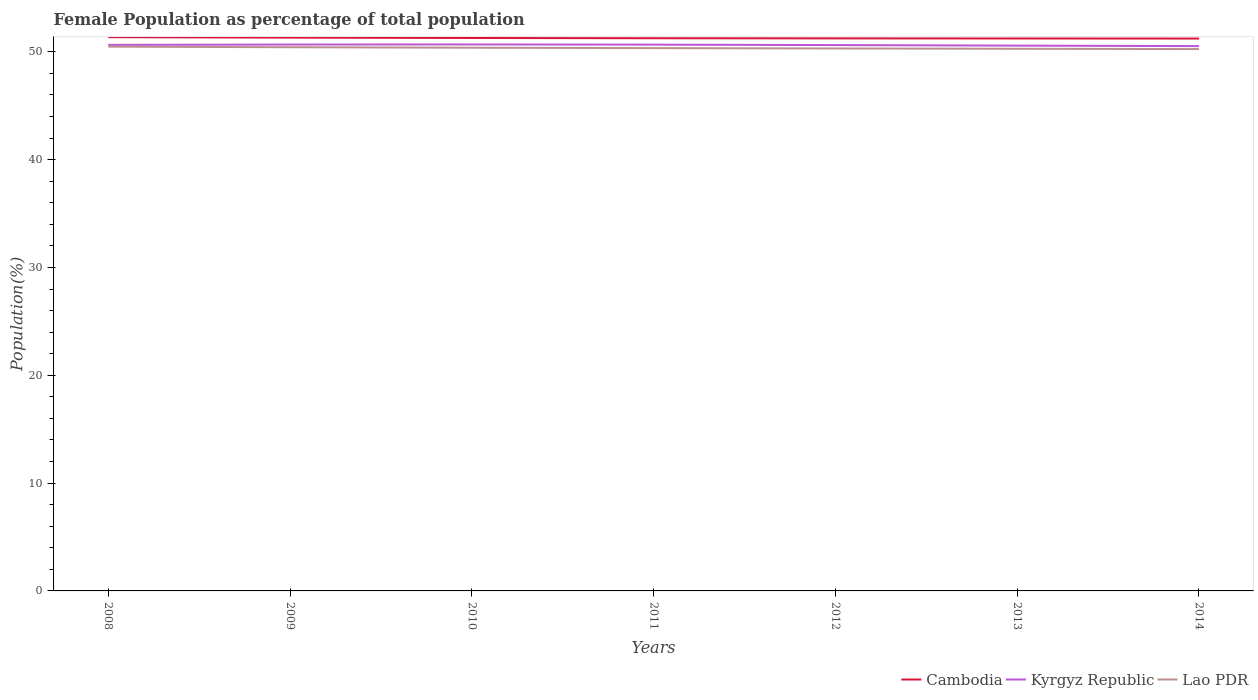How many different coloured lines are there?
Offer a very short reply. 3. Does the line corresponding to Lao PDR intersect with the line corresponding to Kyrgyz Republic?
Make the answer very short. No. Across all years, what is the maximum female population in in Cambodia?
Your answer should be compact. 51.23. What is the total female population in in Kyrgyz Republic in the graph?
Give a very brief answer. -0.03. What is the difference between the highest and the second highest female population in in Cambodia?
Ensure brevity in your answer.  0.13. What is the difference between the highest and the lowest female population in in Kyrgyz Republic?
Keep it short and to the point. 4. Is the female population in in Lao PDR strictly greater than the female population in in Cambodia over the years?
Ensure brevity in your answer.  Yes. How many years are there in the graph?
Provide a succinct answer. 7. Does the graph contain any zero values?
Your response must be concise. No. Where does the legend appear in the graph?
Give a very brief answer. Bottom right. How many legend labels are there?
Your answer should be compact. 3. What is the title of the graph?
Your response must be concise. Female Population as percentage of total population. Does "United States" appear as one of the legend labels in the graph?
Offer a terse response. No. What is the label or title of the X-axis?
Provide a succinct answer. Years. What is the label or title of the Y-axis?
Offer a very short reply. Population(%). What is the Population(%) in Cambodia in 2008?
Give a very brief answer. 51.36. What is the Population(%) of Kyrgyz Republic in 2008?
Make the answer very short. 50.65. What is the Population(%) of Lao PDR in 2008?
Keep it short and to the point. 50.48. What is the Population(%) in Cambodia in 2009?
Make the answer very short. 51.32. What is the Population(%) of Kyrgyz Republic in 2009?
Provide a succinct answer. 50.68. What is the Population(%) of Lao PDR in 2009?
Provide a short and direct response. 50.43. What is the Population(%) in Cambodia in 2010?
Your answer should be very brief. 51.29. What is the Population(%) in Kyrgyz Republic in 2010?
Keep it short and to the point. 50.69. What is the Population(%) in Lao PDR in 2010?
Make the answer very short. 50.38. What is the Population(%) in Cambodia in 2011?
Give a very brief answer. 51.26. What is the Population(%) of Kyrgyz Republic in 2011?
Ensure brevity in your answer.  50.67. What is the Population(%) of Lao PDR in 2011?
Provide a succinct answer. 50.35. What is the Population(%) in Cambodia in 2012?
Make the answer very short. 51.25. What is the Population(%) in Kyrgyz Republic in 2012?
Your answer should be compact. 50.63. What is the Population(%) of Lao PDR in 2012?
Ensure brevity in your answer.  50.31. What is the Population(%) in Cambodia in 2013?
Offer a very short reply. 51.24. What is the Population(%) of Kyrgyz Republic in 2013?
Your response must be concise. 50.58. What is the Population(%) in Lao PDR in 2013?
Offer a very short reply. 50.28. What is the Population(%) of Cambodia in 2014?
Provide a short and direct response. 51.23. What is the Population(%) of Kyrgyz Republic in 2014?
Make the answer very short. 50.53. What is the Population(%) in Lao PDR in 2014?
Make the answer very short. 50.26. Across all years, what is the maximum Population(%) in Cambodia?
Give a very brief answer. 51.36. Across all years, what is the maximum Population(%) of Kyrgyz Republic?
Keep it short and to the point. 50.69. Across all years, what is the maximum Population(%) in Lao PDR?
Offer a terse response. 50.48. Across all years, what is the minimum Population(%) of Cambodia?
Give a very brief answer. 51.23. Across all years, what is the minimum Population(%) of Kyrgyz Republic?
Offer a very short reply. 50.53. Across all years, what is the minimum Population(%) of Lao PDR?
Offer a terse response. 50.26. What is the total Population(%) of Cambodia in the graph?
Provide a succinct answer. 358.95. What is the total Population(%) of Kyrgyz Republic in the graph?
Your response must be concise. 354.42. What is the total Population(%) of Lao PDR in the graph?
Provide a succinct answer. 352.5. What is the difference between the Population(%) of Cambodia in 2008 and that in 2009?
Ensure brevity in your answer.  0.04. What is the difference between the Population(%) of Kyrgyz Republic in 2008 and that in 2009?
Give a very brief answer. -0.03. What is the difference between the Population(%) in Lao PDR in 2008 and that in 2009?
Ensure brevity in your answer.  0.05. What is the difference between the Population(%) in Cambodia in 2008 and that in 2010?
Your answer should be compact. 0.08. What is the difference between the Population(%) of Kyrgyz Republic in 2008 and that in 2010?
Make the answer very short. -0.04. What is the difference between the Population(%) in Lao PDR in 2008 and that in 2010?
Give a very brief answer. 0.1. What is the difference between the Population(%) in Cambodia in 2008 and that in 2011?
Offer a terse response. 0.1. What is the difference between the Population(%) in Kyrgyz Republic in 2008 and that in 2011?
Your response must be concise. -0.02. What is the difference between the Population(%) of Lao PDR in 2008 and that in 2011?
Your response must be concise. 0.14. What is the difference between the Population(%) in Cambodia in 2008 and that in 2012?
Provide a short and direct response. 0.11. What is the difference between the Population(%) of Kyrgyz Republic in 2008 and that in 2012?
Your answer should be very brief. 0.02. What is the difference between the Population(%) in Lao PDR in 2008 and that in 2012?
Give a very brief answer. 0.17. What is the difference between the Population(%) of Cambodia in 2008 and that in 2013?
Your answer should be compact. 0.12. What is the difference between the Population(%) of Kyrgyz Republic in 2008 and that in 2013?
Provide a succinct answer. 0.07. What is the difference between the Population(%) of Lao PDR in 2008 and that in 2013?
Offer a terse response. 0.2. What is the difference between the Population(%) in Cambodia in 2008 and that in 2014?
Provide a succinct answer. 0.13. What is the difference between the Population(%) of Kyrgyz Republic in 2008 and that in 2014?
Your response must be concise. 0.11. What is the difference between the Population(%) of Lao PDR in 2008 and that in 2014?
Your answer should be compact. 0.22. What is the difference between the Population(%) of Cambodia in 2009 and that in 2010?
Offer a very short reply. 0.03. What is the difference between the Population(%) in Kyrgyz Republic in 2009 and that in 2010?
Keep it short and to the point. -0.01. What is the difference between the Population(%) in Lao PDR in 2009 and that in 2010?
Make the answer very short. 0.05. What is the difference between the Population(%) in Cambodia in 2009 and that in 2011?
Make the answer very short. 0.06. What is the difference between the Population(%) of Kyrgyz Republic in 2009 and that in 2011?
Make the answer very short. 0.01. What is the difference between the Population(%) of Lao PDR in 2009 and that in 2011?
Provide a short and direct response. 0.08. What is the difference between the Population(%) of Cambodia in 2009 and that in 2012?
Make the answer very short. 0.07. What is the difference between the Population(%) in Kyrgyz Republic in 2009 and that in 2012?
Ensure brevity in your answer.  0.05. What is the difference between the Population(%) of Lao PDR in 2009 and that in 2012?
Your answer should be compact. 0.12. What is the difference between the Population(%) in Cambodia in 2009 and that in 2013?
Offer a terse response. 0.08. What is the difference between the Population(%) in Kyrgyz Republic in 2009 and that in 2013?
Provide a short and direct response. 0.1. What is the difference between the Population(%) in Lao PDR in 2009 and that in 2013?
Provide a short and direct response. 0.14. What is the difference between the Population(%) in Cambodia in 2009 and that in 2014?
Offer a very short reply. 0.09. What is the difference between the Population(%) in Kyrgyz Republic in 2009 and that in 2014?
Your answer should be compact. 0.15. What is the difference between the Population(%) of Lao PDR in 2009 and that in 2014?
Your answer should be compact. 0.17. What is the difference between the Population(%) in Cambodia in 2010 and that in 2011?
Your answer should be compact. 0.02. What is the difference between the Population(%) of Kyrgyz Republic in 2010 and that in 2011?
Provide a succinct answer. 0.02. What is the difference between the Population(%) of Lao PDR in 2010 and that in 2011?
Give a very brief answer. 0.04. What is the difference between the Population(%) of Cambodia in 2010 and that in 2012?
Give a very brief answer. 0.04. What is the difference between the Population(%) of Kyrgyz Republic in 2010 and that in 2012?
Your response must be concise. 0.06. What is the difference between the Population(%) of Lao PDR in 2010 and that in 2012?
Offer a terse response. 0.07. What is the difference between the Population(%) in Cambodia in 2010 and that in 2013?
Make the answer very short. 0.05. What is the difference between the Population(%) of Kyrgyz Republic in 2010 and that in 2013?
Your answer should be very brief. 0.11. What is the difference between the Population(%) in Lao PDR in 2010 and that in 2013?
Offer a very short reply. 0.1. What is the difference between the Population(%) in Cambodia in 2010 and that in 2014?
Offer a very short reply. 0.05. What is the difference between the Population(%) in Kyrgyz Republic in 2010 and that in 2014?
Your response must be concise. 0.16. What is the difference between the Population(%) of Lao PDR in 2010 and that in 2014?
Provide a short and direct response. 0.13. What is the difference between the Population(%) in Cambodia in 2011 and that in 2012?
Provide a succinct answer. 0.01. What is the difference between the Population(%) of Kyrgyz Republic in 2011 and that in 2012?
Your answer should be compact. 0.04. What is the difference between the Population(%) in Lao PDR in 2011 and that in 2012?
Your answer should be very brief. 0.03. What is the difference between the Population(%) of Cambodia in 2011 and that in 2013?
Your answer should be compact. 0.02. What is the difference between the Population(%) of Kyrgyz Republic in 2011 and that in 2013?
Your response must be concise. 0.09. What is the difference between the Population(%) in Lao PDR in 2011 and that in 2013?
Your answer should be compact. 0.06. What is the difference between the Population(%) in Cambodia in 2011 and that in 2014?
Ensure brevity in your answer.  0.03. What is the difference between the Population(%) of Kyrgyz Republic in 2011 and that in 2014?
Give a very brief answer. 0.14. What is the difference between the Population(%) of Lao PDR in 2011 and that in 2014?
Provide a short and direct response. 0.09. What is the difference between the Population(%) of Cambodia in 2012 and that in 2013?
Keep it short and to the point. 0.01. What is the difference between the Population(%) of Kyrgyz Republic in 2012 and that in 2013?
Your answer should be compact. 0.05. What is the difference between the Population(%) of Lao PDR in 2012 and that in 2013?
Make the answer very short. 0.03. What is the difference between the Population(%) of Cambodia in 2012 and that in 2014?
Provide a short and direct response. 0.02. What is the difference between the Population(%) of Kyrgyz Republic in 2012 and that in 2014?
Offer a terse response. 0.1. What is the difference between the Population(%) of Lao PDR in 2012 and that in 2014?
Give a very brief answer. 0.06. What is the difference between the Population(%) of Cambodia in 2013 and that in 2014?
Provide a short and direct response. 0.01. What is the difference between the Population(%) of Kyrgyz Republic in 2013 and that in 2014?
Your answer should be compact. 0.05. What is the difference between the Population(%) of Lao PDR in 2013 and that in 2014?
Offer a very short reply. 0.03. What is the difference between the Population(%) of Cambodia in 2008 and the Population(%) of Kyrgyz Republic in 2009?
Provide a short and direct response. 0.68. What is the difference between the Population(%) in Cambodia in 2008 and the Population(%) in Lao PDR in 2009?
Keep it short and to the point. 0.93. What is the difference between the Population(%) of Kyrgyz Republic in 2008 and the Population(%) of Lao PDR in 2009?
Make the answer very short. 0.22. What is the difference between the Population(%) of Cambodia in 2008 and the Population(%) of Kyrgyz Republic in 2010?
Offer a terse response. 0.67. What is the difference between the Population(%) in Kyrgyz Republic in 2008 and the Population(%) in Lao PDR in 2010?
Ensure brevity in your answer.  0.26. What is the difference between the Population(%) of Cambodia in 2008 and the Population(%) of Kyrgyz Republic in 2011?
Offer a terse response. 0.69. What is the difference between the Population(%) in Cambodia in 2008 and the Population(%) in Lao PDR in 2011?
Offer a terse response. 1.02. What is the difference between the Population(%) in Kyrgyz Republic in 2008 and the Population(%) in Lao PDR in 2011?
Ensure brevity in your answer.  0.3. What is the difference between the Population(%) in Cambodia in 2008 and the Population(%) in Kyrgyz Republic in 2012?
Your answer should be very brief. 0.73. What is the difference between the Population(%) in Cambodia in 2008 and the Population(%) in Lao PDR in 2012?
Keep it short and to the point. 1.05. What is the difference between the Population(%) of Kyrgyz Republic in 2008 and the Population(%) of Lao PDR in 2012?
Provide a short and direct response. 0.33. What is the difference between the Population(%) in Cambodia in 2008 and the Population(%) in Kyrgyz Republic in 2013?
Ensure brevity in your answer.  0.78. What is the difference between the Population(%) of Cambodia in 2008 and the Population(%) of Lao PDR in 2013?
Offer a terse response. 1.08. What is the difference between the Population(%) of Kyrgyz Republic in 2008 and the Population(%) of Lao PDR in 2013?
Offer a terse response. 0.36. What is the difference between the Population(%) in Cambodia in 2008 and the Population(%) in Kyrgyz Republic in 2014?
Your answer should be compact. 0.83. What is the difference between the Population(%) of Cambodia in 2008 and the Population(%) of Lao PDR in 2014?
Your answer should be compact. 1.1. What is the difference between the Population(%) of Kyrgyz Republic in 2008 and the Population(%) of Lao PDR in 2014?
Offer a very short reply. 0.39. What is the difference between the Population(%) in Cambodia in 2009 and the Population(%) in Kyrgyz Republic in 2010?
Make the answer very short. 0.63. What is the difference between the Population(%) of Cambodia in 2009 and the Population(%) of Lao PDR in 2010?
Make the answer very short. 0.94. What is the difference between the Population(%) in Kyrgyz Republic in 2009 and the Population(%) in Lao PDR in 2010?
Your answer should be very brief. 0.3. What is the difference between the Population(%) of Cambodia in 2009 and the Population(%) of Kyrgyz Republic in 2011?
Your answer should be compact. 0.65. What is the difference between the Population(%) in Cambodia in 2009 and the Population(%) in Lao PDR in 2011?
Make the answer very short. 0.97. What is the difference between the Population(%) in Kyrgyz Republic in 2009 and the Population(%) in Lao PDR in 2011?
Offer a very short reply. 0.33. What is the difference between the Population(%) of Cambodia in 2009 and the Population(%) of Kyrgyz Republic in 2012?
Make the answer very short. 0.69. What is the difference between the Population(%) of Cambodia in 2009 and the Population(%) of Lao PDR in 2012?
Offer a very short reply. 1.01. What is the difference between the Population(%) in Kyrgyz Republic in 2009 and the Population(%) in Lao PDR in 2012?
Provide a short and direct response. 0.37. What is the difference between the Population(%) of Cambodia in 2009 and the Population(%) of Kyrgyz Republic in 2013?
Provide a short and direct response. 0.74. What is the difference between the Population(%) of Cambodia in 2009 and the Population(%) of Lao PDR in 2013?
Give a very brief answer. 1.03. What is the difference between the Population(%) of Kyrgyz Republic in 2009 and the Population(%) of Lao PDR in 2013?
Give a very brief answer. 0.39. What is the difference between the Population(%) in Cambodia in 2009 and the Population(%) in Kyrgyz Republic in 2014?
Make the answer very short. 0.79. What is the difference between the Population(%) in Cambodia in 2009 and the Population(%) in Lao PDR in 2014?
Provide a short and direct response. 1.06. What is the difference between the Population(%) in Kyrgyz Republic in 2009 and the Population(%) in Lao PDR in 2014?
Your answer should be very brief. 0.42. What is the difference between the Population(%) in Cambodia in 2010 and the Population(%) in Kyrgyz Republic in 2011?
Make the answer very short. 0.62. What is the difference between the Population(%) in Cambodia in 2010 and the Population(%) in Lao PDR in 2011?
Provide a succinct answer. 0.94. What is the difference between the Population(%) of Kyrgyz Republic in 2010 and the Population(%) of Lao PDR in 2011?
Keep it short and to the point. 0.34. What is the difference between the Population(%) in Cambodia in 2010 and the Population(%) in Kyrgyz Republic in 2012?
Give a very brief answer. 0.66. What is the difference between the Population(%) of Cambodia in 2010 and the Population(%) of Lao PDR in 2012?
Offer a terse response. 0.97. What is the difference between the Population(%) in Kyrgyz Republic in 2010 and the Population(%) in Lao PDR in 2012?
Provide a short and direct response. 0.37. What is the difference between the Population(%) of Cambodia in 2010 and the Population(%) of Kyrgyz Republic in 2013?
Your answer should be compact. 0.71. What is the difference between the Population(%) of Kyrgyz Republic in 2010 and the Population(%) of Lao PDR in 2013?
Make the answer very short. 0.4. What is the difference between the Population(%) of Cambodia in 2010 and the Population(%) of Kyrgyz Republic in 2014?
Offer a terse response. 0.75. What is the difference between the Population(%) in Cambodia in 2010 and the Population(%) in Lao PDR in 2014?
Provide a succinct answer. 1.03. What is the difference between the Population(%) of Kyrgyz Republic in 2010 and the Population(%) of Lao PDR in 2014?
Your response must be concise. 0.43. What is the difference between the Population(%) of Cambodia in 2011 and the Population(%) of Kyrgyz Republic in 2012?
Your response must be concise. 0.63. What is the difference between the Population(%) in Cambodia in 2011 and the Population(%) in Lao PDR in 2012?
Offer a terse response. 0.95. What is the difference between the Population(%) of Kyrgyz Republic in 2011 and the Population(%) of Lao PDR in 2012?
Offer a very short reply. 0.36. What is the difference between the Population(%) in Cambodia in 2011 and the Population(%) in Kyrgyz Republic in 2013?
Provide a succinct answer. 0.69. What is the difference between the Population(%) in Cambodia in 2011 and the Population(%) in Lao PDR in 2013?
Ensure brevity in your answer.  0.98. What is the difference between the Population(%) in Kyrgyz Republic in 2011 and the Population(%) in Lao PDR in 2013?
Provide a succinct answer. 0.38. What is the difference between the Population(%) of Cambodia in 2011 and the Population(%) of Kyrgyz Republic in 2014?
Your answer should be compact. 0.73. What is the difference between the Population(%) in Cambodia in 2011 and the Population(%) in Lao PDR in 2014?
Provide a short and direct response. 1. What is the difference between the Population(%) in Kyrgyz Republic in 2011 and the Population(%) in Lao PDR in 2014?
Provide a short and direct response. 0.41. What is the difference between the Population(%) in Cambodia in 2012 and the Population(%) in Kyrgyz Republic in 2013?
Your answer should be compact. 0.67. What is the difference between the Population(%) in Cambodia in 2012 and the Population(%) in Lao PDR in 2013?
Ensure brevity in your answer.  0.96. What is the difference between the Population(%) of Kyrgyz Republic in 2012 and the Population(%) of Lao PDR in 2013?
Give a very brief answer. 0.34. What is the difference between the Population(%) in Cambodia in 2012 and the Population(%) in Kyrgyz Republic in 2014?
Make the answer very short. 0.72. What is the difference between the Population(%) in Cambodia in 2012 and the Population(%) in Lao PDR in 2014?
Offer a very short reply. 0.99. What is the difference between the Population(%) in Kyrgyz Republic in 2012 and the Population(%) in Lao PDR in 2014?
Ensure brevity in your answer.  0.37. What is the difference between the Population(%) in Cambodia in 2013 and the Population(%) in Kyrgyz Republic in 2014?
Provide a short and direct response. 0.71. What is the difference between the Population(%) in Cambodia in 2013 and the Population(%) in Lao PDR in 2014?
Your answer should be compact. 0.98. What is the difference between the Population(%) of Kyrgyz Republic in 2013 and the Population(%) of Lao PDR in 2014?
Make the answer very short. 0.32. What is the average Population(%) in Cambodia per year?
Offer a terse response. 51.28. What is the average Population(%) of Kyrgyz Republic per year?
Offer a terse response. 50.63. What is the average Population(%) in Lao PDR per year?
Offer a very short reply. 50.36. In the year 2008, what is the difference between the Population(%) of Cambodia and Population(%) of Kyrgyz Republic?
Offer a very short reply. 0.72. In the year 2008, what is the difference between the Population(%) in Cambodia and Population(%) in Lao PDR?
Your answer should be compact. 0.88. In the year 2008, what is the difference between the Population(%) in Kyrgyz Republic and Population(%) in Lao PDR?
Offer a very short reply. 0.16. In the year 2009, what is the difference between the Population(%) of Cambodia and Population(%) of Kyrgyz Republic?
Your answer should be very brief. 0.64. In the year 2009, what is the difference between the Population(%) of Cambodia and Population(%) of Lao PDR?
Provide a short and direct response. 0.89. In the year 2009, what is the difference between the Population(%) in Kyrgyz Republic and Population(%) in Lao PDR?
Keep it short and to the point. 0.25. In the year 2010, what is the difference between the Population(%) of Cambodia and Population(%) of Kyrgyz Republic?
Keep it short and to the point. 0.6. In the year 2010, what is the difference between the Population(%) in Cambodia and Population(%) in Lao PDR?
Give a very brief answer. 0.9. In the year 2010, what is the difference between the Population(%) in Kyrgyz Republic and Population(%) in Lao PDR?
Give a very brief answer. 0.3. In the year 2011, what is the difference between the Population(%) of Cambodia and Population(%) of Kyrgyz Republic?
Ensure brevity in your answer.  0.59. In the year 2011, what is the difference between the Population(%) in Cambodia and Population(%) in Lao PDR?
Make the answer very short. 0.92. In the year 2011, what is the difference between the Population(%) of Kyrgyz Republic and Population(%) of Lao PDR?
Make the answer very short. 0.32. In the year 2012, what is the difference between the Population(%) in Cambodia and Population(%) in Kyrgyz Republic?
Offer a very short reply. 0.62. In the year 2012, what is the difference between the Population(%) of Cambodia and Population(%) of Lao PDR?
Give a very brief answer. 0.94. In the year 2012, what is the difference between the Population(%) in Kyrgyz Republic and Population(%) in Lao PDR?
Offer a very short reply. 0.31. In the year 2013, what is the difference between the Population(%) in Cambodia and Population(%) in Kyrgyz Republic?
Keep it short and to the point. 0.66. In the year 2013, what is the difference between the Population(%) of Cambodia and Population(%) of Lao PDR?
Offer a very short reply. 0.96. In the year 2013, what is the difference between the Population(%) of Kyrgyz Republic and Population(%) of Lao PDR?
Offer a terse response. 0.29. In the year 2014, what is the difference between the Population(%) of Cambodia and Population(%) of Kyrgyz Republic?
Make the answer very short. 0.7. In the year 2014, what is the difference between the Population(%) of Cambodia and Population(%) of Lao PDR?
Ensure brevity in your answer.  0.98. In the year 2014, what is the difference between the Population(%) in Kyrgyz Republic and Population(%) in Lao PDR?
Keep it short and to the point. 0.27. What is the ratio of the Population(%) of Kyrgyz Republic in 2008 to that in 2009?
Your response must be concise. 1. What is the ratio of the Population(%) in Kyrgyz Republic in 2008 to that in 2010?
Offer a very short reply. 1. What is the ratio of the Population(%) in Kyrgyz Republic in 2008 to that in 2011?
Make the answer very short. 1. What is the ratio of the Population(%) in Lao PDR in 2008 to that in 2011?
Your answer should be very brief. 1. What is the ratio of the Population(%) in Cambodia in 2008 to that in 2012?
Make the answer very short. 1. What is the ratio of the Population(%) of Kyrgyz Republic in 2008 to that in 2012?
Ensure brevity in your answer.  1. What is the ratio of the Population(%) of Cambodia in 2008 to that in 2013?
Your answer should be compact. 1. What is the ratio of the Population(%) of Cambodia in 2008 to that in 2014?
Make the answer very short. 1. What is the ratio of the Population(%) of Kyrgyz Republic in 2008 to that in 2014?
Provide a succinct answer. 1. What is the ratio of the Population(%) in Lao PDR in 2008 to that in 2014?
Offer a very short reply. 1. What is the ratio of the Population(%) of Lao PDR in 2009 to that in 2010?
Your answer should be very brief. 1. What is the ratio of the Population(%) of Cambodia in 2009 to that in 2011?
Offer a terse response. 1. What is the ratio of the Population(%) in Cambodia in 2009 to that in 2012?
Give a very brief answer. 1. What is the ratio of the Population(%) in Lao PDR in 2009 to that in 2012?
Offer a very short reply. 1. What is the ratio of the Population(%) in Lao PDR in 2009 to that in 2013?
Your answer should be compact. 1. What is the ratio of the Population(%) in Kyrgyz Republic in 2009 to that in 2014?
Your response must be concise. 1. What is the ratio of the Population(%) in Lao PDR in 2009 to that in 2014?
Provide a succinct answer. 1. What is the ratio of the Population(%) in Cambodia in 2010 to that in 2012?
Offer a terse response. 1. What is the ratio of the Population(%) of Lao PDR in 2010 to that in 2012?
Ensure brevity in your answer.  1. What is the ratio of the Population(%) of Cambodia in 2010 to that in 2013?
Keep it short and to the point. 1. What is the ratio of the Population(%) of Kyrgyz Republic in 2010 to that in 2013?
Make the answer very short. 1. What is the ratio of the Population(%) in Cambodia in 2010 to that in 2014?
Give a very brief answer. 1. What is the ratio of the Population(%) of Lao PDR in 2011 to that in 2012?
Ensure brevity in your answer.  1. What is the ratio of the Population(%) of Kyrgyz Republic in 2011 to that in 2013?
Offer a terse response. 1. What is the ratio of the Population(%) of Kyrgyz Republic in 2011 to that in 2014?
Provide a short and direct response. 1. What is the ratio of the Population(%) in Lao PDR in 2011 to that in 2014?
Your response must be concise. 1. What is the ratio of the Population(%) in Cambodia in 2012 to that in 2013?
Keep it short and to the point. 1. What is the ratio of the Population(%) of Lao PDR in 2012 to that in 2013?
Provide a short and direct response. 1. What is the ratio of the Population(%) of Cambodia in 2012 to that in 2014?
Ensure brevity in your answer.  1. What is the ratio of the Population(%) in Lao PDR in 2012 to that in 2014?
Your answer should be compact. 1. What is the ratio of the Population(%) in Kyrgyz Republic in 2013 to that in 2014?
Offer a terse response. 1. What is the difference between the highest and the second highest Population(%) of Cambodia?
Keep it short and to the point. 0.04. What is the difference between the highest and the second highest Population(%) in Kyrgyz Republic?
Your response must be concise. 0.01. What is the difference between the highest and the second highest Population(%) of Lao PDR?
Ensure brevity in your answer.  0.05. What is the difference between the highest and the lowest Population(%) of Cambodia?
Give a very brief answer. 0.13. What is the difference between the highest and the lowest Population(%) in Kyrgyz Republic?
Keep it short and to the point. 0.16. What is the difference between the highest and the lowest Population(%) of Lao PDR?
Your answer should be compact. 0.22. 